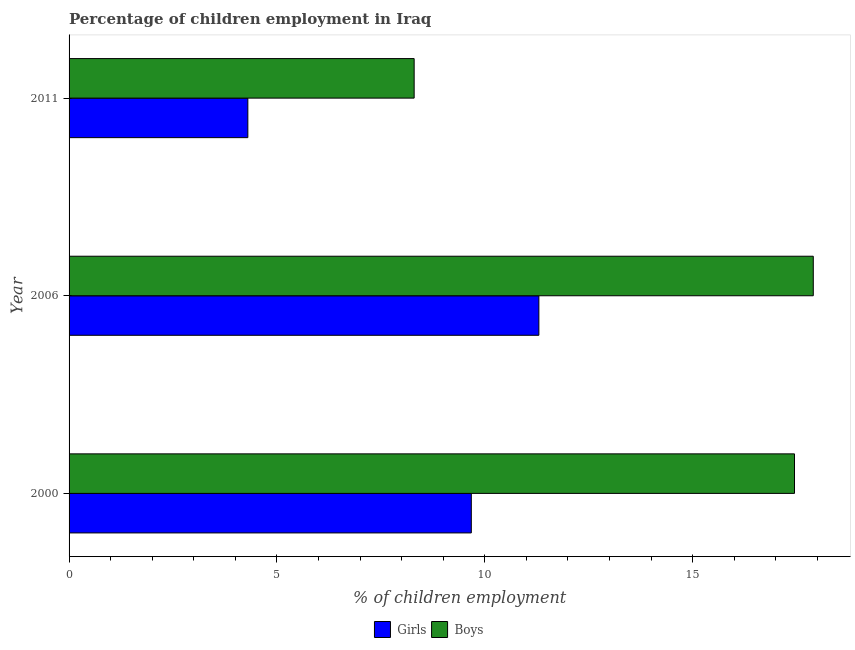Are the number of bars per tick equal to the number of legend labels?
Give a very brief answer. Yes. How many bars are there on the 2nd tick from the top?
Your answer should be very brief. 2. How many bars are there on the 3rd tick from the bottom?
Make the answer very short. 2. What is the label of the 2nd group of bars from the top?
Give a very brief answer. 2006. What is the percentage of employed boys in 2000?
Provide a succinct answer. 17.45. Across all years, what is the minimum percentage of employed girls?
Make the answer very short. 4.3. What is the total percentage of employed girls in the graph?
Keep it short and to the point. 25.27. What is the difference between the percentage of employed girls in 2006 and that in 2011?
Give a very brief answer. 7. What is the difference between the percentage of employed girls in 2000 and the percentage of employed boys in 2006?
Your response must be concise. -8.23. What is the average percentage of employed girls per year?
Your answer should be compact. 8.43. In the year 2000, what is the difference between the percentage of employed boys and percentage of employed girls?
Make the answer very short. 7.77. What is the ratio of the percentage of employed girls in 2000 to that in 2011?
Keep it short and to the point. 2.25. Is the percentage of employed boys in 2006 less than that in 2011?
Keep it short and to the point. No. What is the difference between the highest and the second highest percentage of employed girls?
Your answer should be compact. 1.62. What is the difference between the highest and the lowest percentage of employed girls?
Offer a terse response. 7. Is the sum of the percentage of employed boys in 2000 and 2011 greater than the maximum percentage of employed girls across all years?
Keep it short and to the point. Yes. What does the 1st bar from the top in 2011 represents?
Ensure brevity in your answer.  Boys. What does the 1st bar from the bottom in 2000 represents?
Your answer should be compact. Girls. How many bars are there?
Offer a terse response. 6. Are all the bars in the graph horizontal?
Provide a succinct answer. Yes. Does the graph contain grids?
Offer a very short reply. No. Where does the legend appear in the graph?
Offer a terse response. Bottom center. How many legend labels are there?
Offer a very short reply. 2. What is the title of the graph?
Make the answer very short. Percentage of children employment in Iraq. Does "Urban Population" appear as one of the legend labels in the graph?
Offer a very short reply. No. What is the label or title of the X-axis?
Ensure brevity in your answer.  % of children employment. What is the % of children employment in Girls in 2000?
Your answer should be very brief. 9.67. What is the % of children employment in Boys in 2000?
Ensure brevity in your answer.  17.45. What is the % of children employment of Girls in 2006?
Your answer should be compact. 11.3. What is the % of children employment of Boys in 2006?
Give a very brief answer. 17.9. What is the % of children employment in Boys in 2011?
Provide a succinct answer. 8.3. Across all years, what is the maximum % of children employment of Girls?
Ensure brevity in your answer.  11.3. Across all years, what is the maximum % of children employment of Boys?
Ensure brevity in your answer.  17.9. Across all years, what is the minimum % of children employment in Girls?
Offer a very short reply. 4.3. What is the total % of children employment in Girls in the graph?
Your answer should be very brief. 25.27. What is the total % of children employment in Boys in the graph?
Provide a short and direct response. 43.65. What is the difference between the % of children employment of Girls in 2000 and that in 2006?
Keep it short and to the point. -1.63. What is the difference between the % of children employment of Boys in 2000 and that in 2006?
Ensure brevity in your answer.  -0.45. What is the difference between the % of children employment in Girls in 2000 and that in 2011?
Keep it short and to the point. 5.37. What is the difference between the % of children employment of Boys in 2000 and that in 2011?
Your answer should be compact. 9.15. What is the difference between the % of children employment in Girls in 2006 and that in 2011?
Make the answer very short. 7. What is the difference between the % of children employment of Boys in 2006 and that in 2011?
Keep it short and to the point. 9.6. What is the difference between the % of children employment in Girls in 2000 and the % of children employment in Boys in 2006?
Keep it short and to the point. -8.23. What is the difference between the % of children employment of Girls in 2000 and the % of children employment of Boys in 2011?
Ensure brevity in your answer.  1.37. What is the average % of children employment of Girls per year?
Ensure brevity in your answer.  8.43. What is the average % of children employment of Boys per year?
Keep it short and to the point. 14.55. In the year 2000, what is the difference between the % of children employment of Girls and % of children employment of Boys?
Provide a succinct answer. -7.77. In the year 2006, what is the difference between the % of children employment in Girls and % of children employment in Boys?
Keep it short and to the point. -6.6. In the year 2011, what is the difference between the % of children employment of Girls and % of children employment of Boys?
Your response must be concise. -4. What is the ratio of the % of children employment in Girls in 2000 to that in 2006?
Your response must be concise. 0.86. What is the ratio of the % of children employment in Boys in 2000 to that in 2006?
Make the answer very short. 0.97. What is the ratio of the % of children employment in Girls in 2000 to that in 2011?
Provide a short and direct response. 2.25. What is the ratio of the % of children employment in Boys in 2000 to that in 2011?
Your response must be concise. 2.1. What is the ratio of the % of children employment in Girls in 2006 to that in 2011?
Offer a terse response. 2.63. What is the ratio of the % of children employment of Boys in 2006 to that in 2011?
Your response must be concise. 2.16. What is the difference between the highest and the second highest % of children employment of Girls?
Keep it short and to the point. 1.63. What is the difference between the highest and the second highest % of children employment in Boys?
Your answer should be very brief. 0.45. What is the difference between the highest and the lowest % of children employment in Girls?
Your answer should be very brief. 7. What is the difference between the highest and the lowest % of children employment of Boys?
Your answer should be very brief. 9.6. 